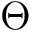Convert formula to latex. <formula><loc_0><loc_0><loc_500><loc_500>\Theta</formula> 